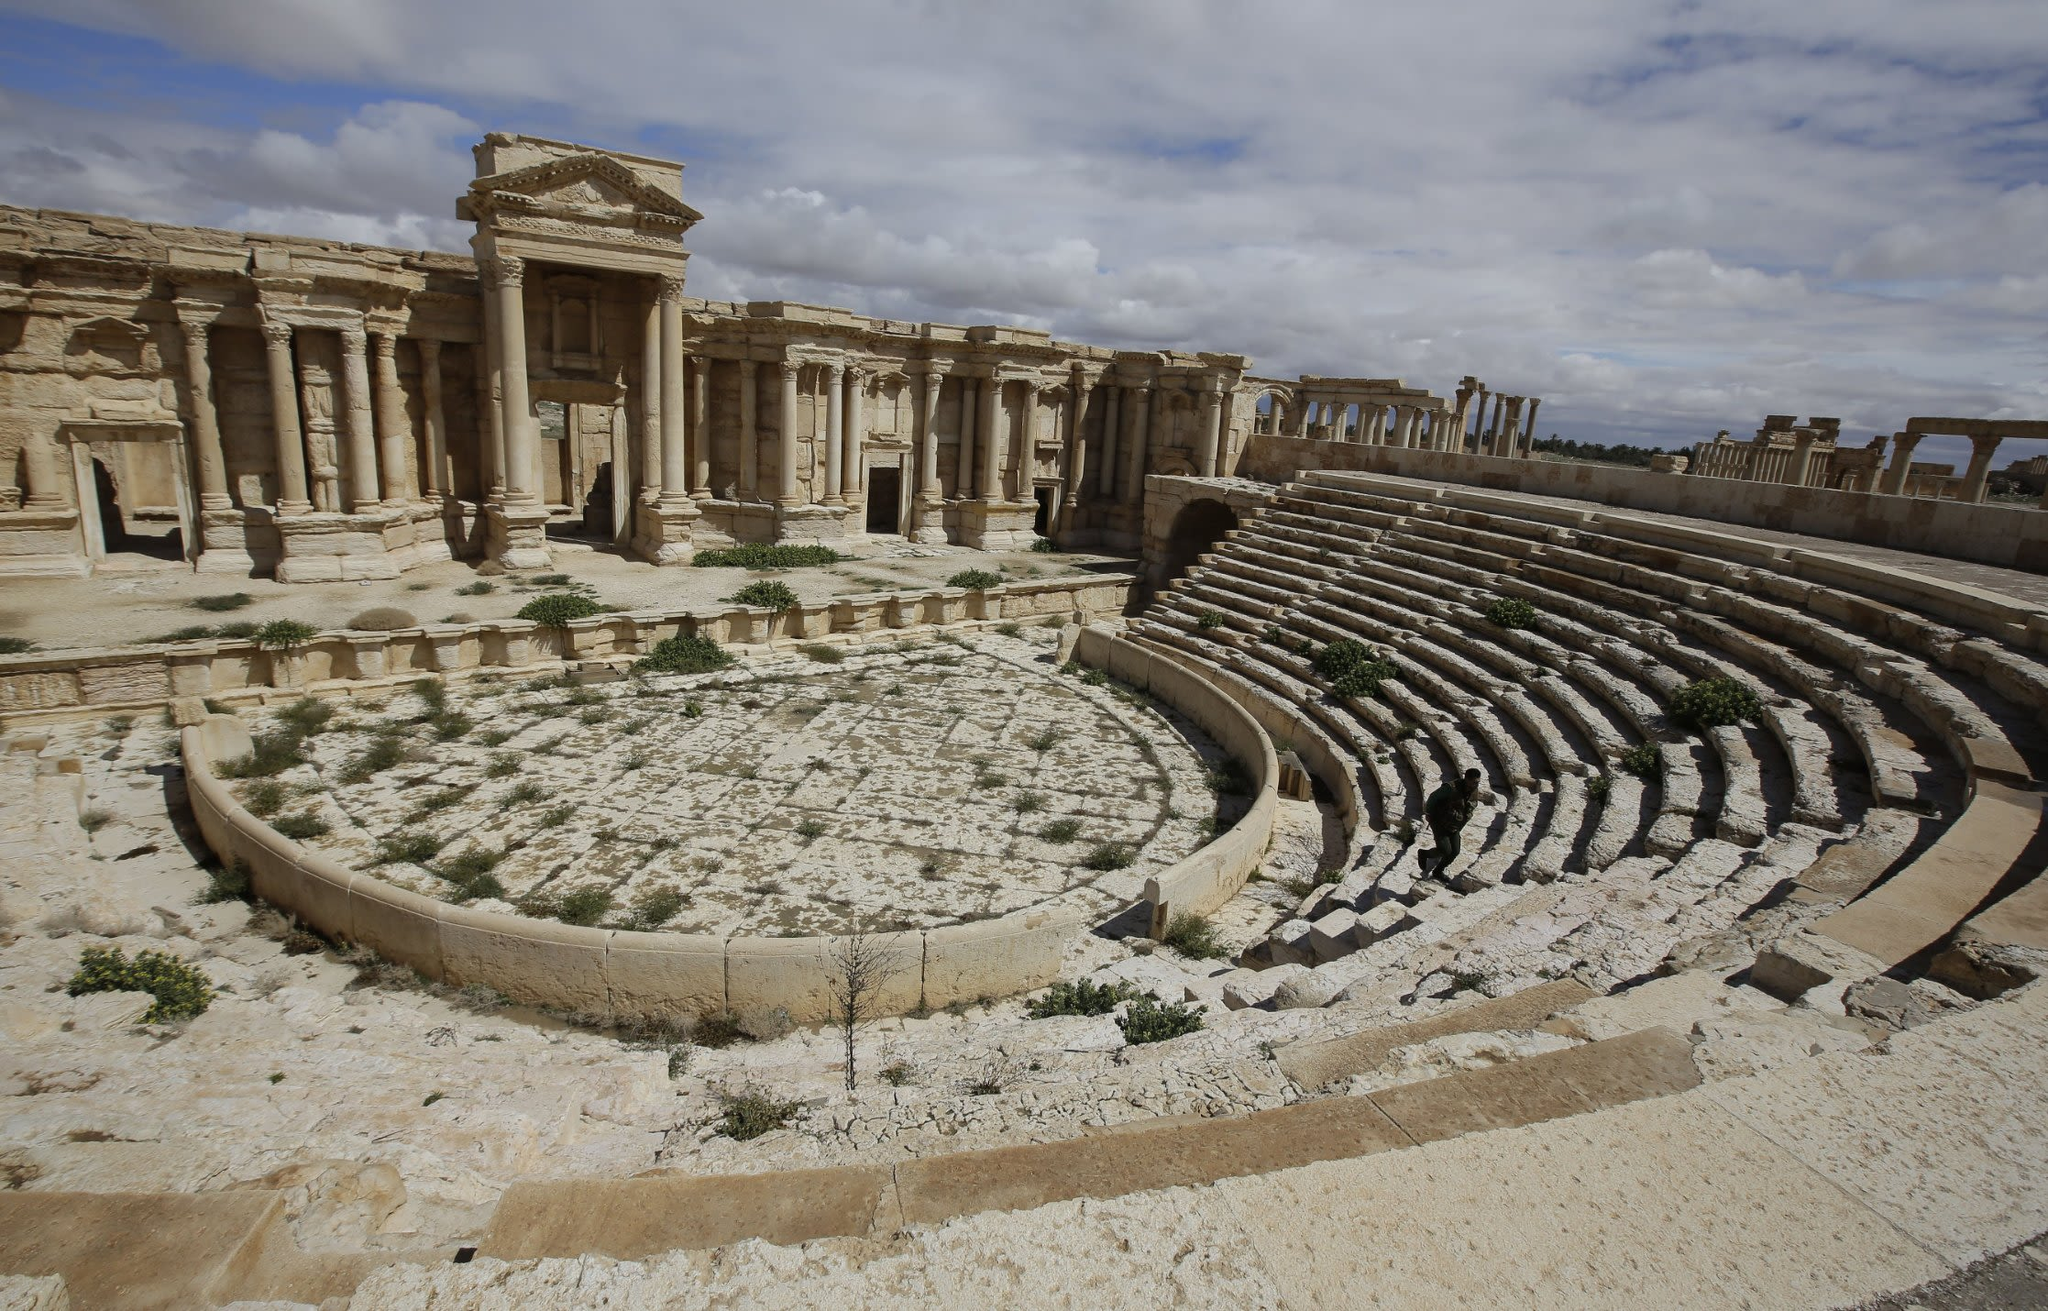Can you tell me more about the historical significance of this theater? Certainly! The theater in Palmyra is a marvelous testament to the Roman influence on the city, believed to have been constructed in the 2nd century AD. This amphitheater, like many Roman theaters, was a central hub for entertainment and social gatherings. It would have hosted a variety of performances, including dramatic plays, musical events, and possibly even gladiatorial games. Palmyra itself was a critical cultural and trading hub, situated at the crossroads of several civilizations, which is reflected in the architectural splendor of the theater. Its grandeur not only represents the artistic accomplishments of its time but also speaks to the socio-political and economic significance of Palmyra within the Roman Empire. 